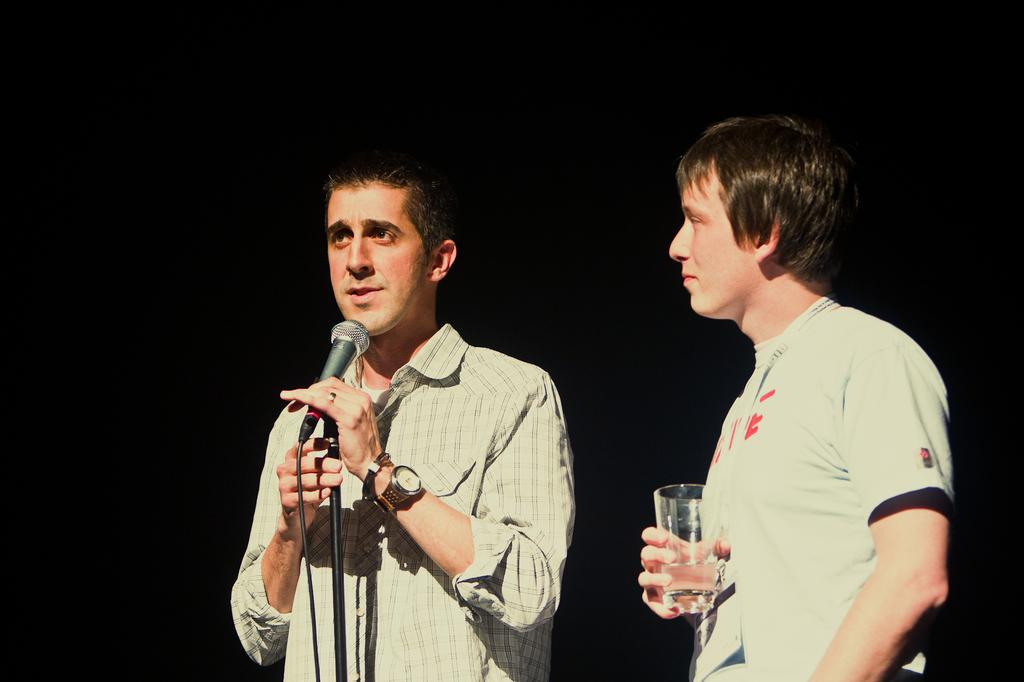How many people are in the image? There are two people in the image. What is one person holding in the image? One person is holding a microphone. What is the other person holding in the image? The other person is holding a glass. How many ducks are visible in the image? There are no ducks present in the image. What type of shock can be seen on the person holding the microphone? There is no shock visible on the person holding the microphone in the image. 